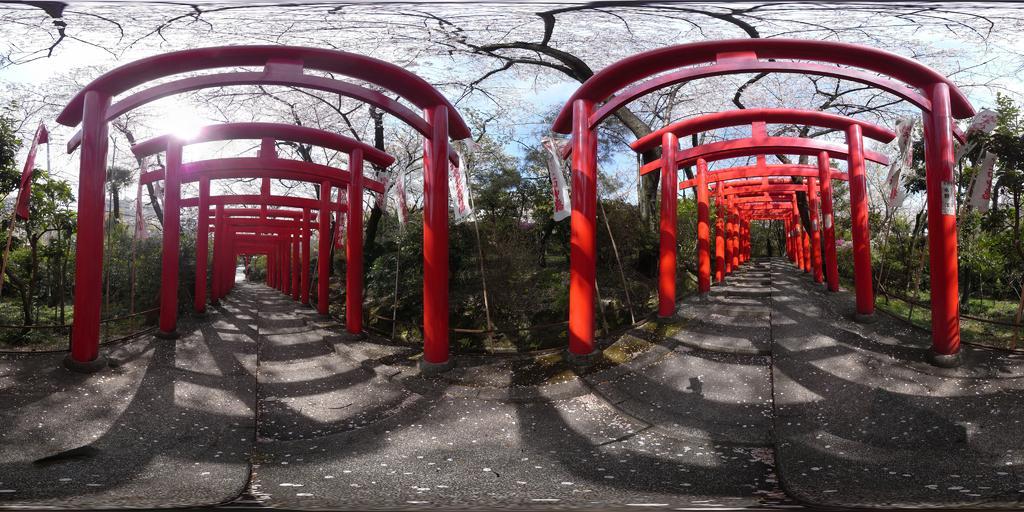Please provide a concise description of this image. I see that this is a collage image and I see there are number of red color rods and I see the flags. I can also see the path. In the background I see the trees and the sky and I see the sun over here. 